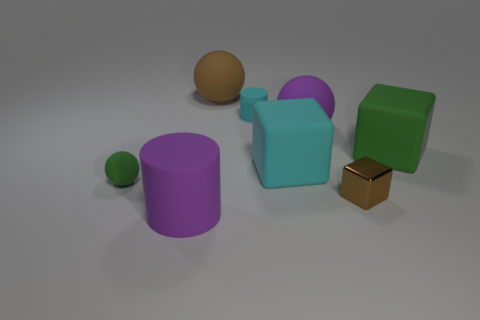Subtract all tiny matte spheres. How many spheres are left? 2 Subtract all green spheres. How many green cubes are left? 1 Add 2 large red spheres. How many objects exist? 10 Subtract all green blocks. How many blocks are left? 2 Subtract 0 yellow cubes. How many objects are left? 8 Subtract all balls. How many objects are left? 5 Subtract 1 blocks. How many blocks are left? 2 Subtract all blue balls. Subtract all yellow cylinders. How many balls are left? 3 Subtract all purple rubber objects. Subtract all cyan rubber things. How many objects are left? 4 Add 1 tiny brown metallic cubes. How many tiny brown metallic cubes are left? 2 